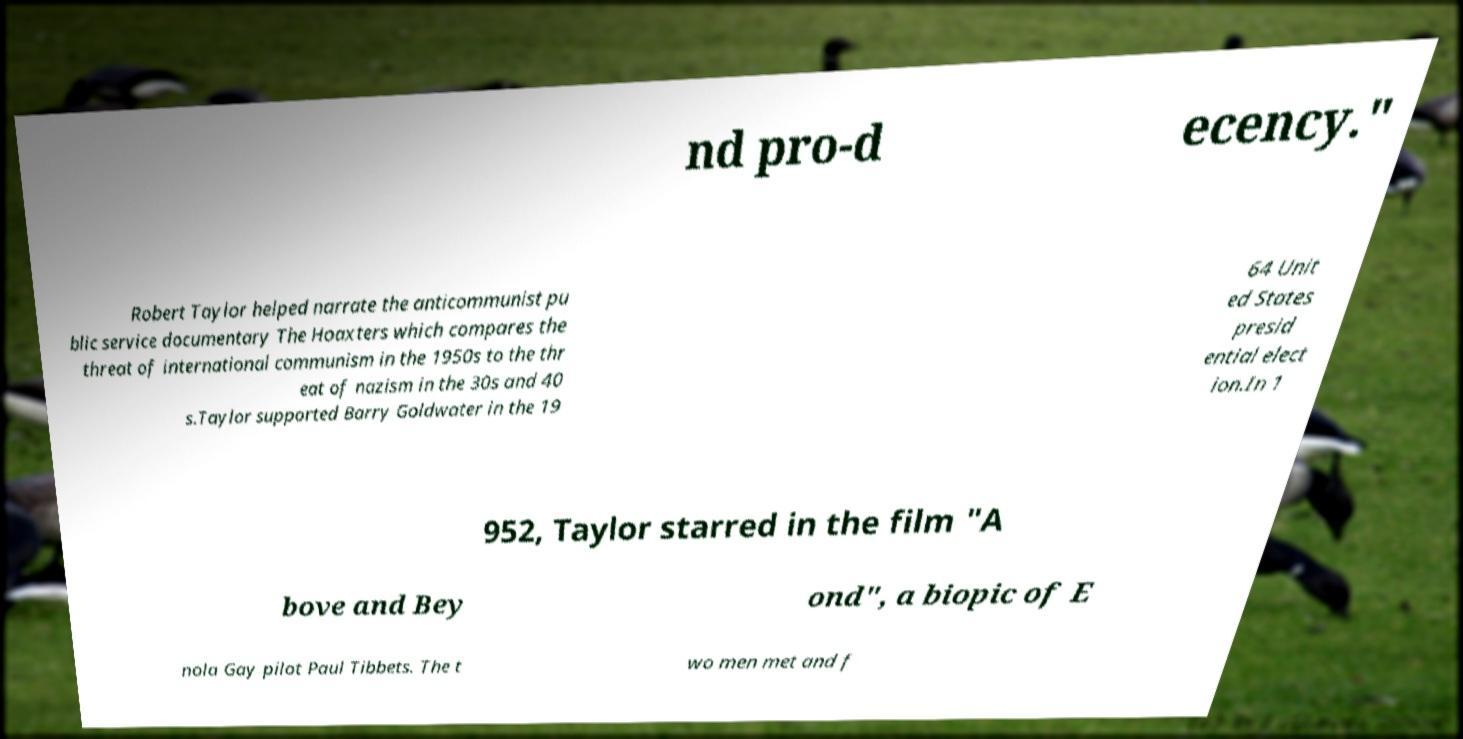There's text embedded in this image that I need extracted. Can you transcribe it verbatim? nd pro-d ecency." Robert Taylor helped narrate the anticommunist pu blic service documentary The Hoaxters which compares the threat of international communism in the 1950s to the thr eat of nazism in the 30s and 40 s.Taylor supported Barry Goldwater in the 19 64 Unit ed States presid ential elect ion.In 1 952, Taylor starred in the film "A bove and Bey ond", a biopic of E nola Gay pilot Paul Tibbets. The t wo men met and f 